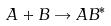Convert formula to latex. <formula><loc_0><loc_0><loc_500><loc_500>A + B \rightarrow A B ^ { * }</formula> 